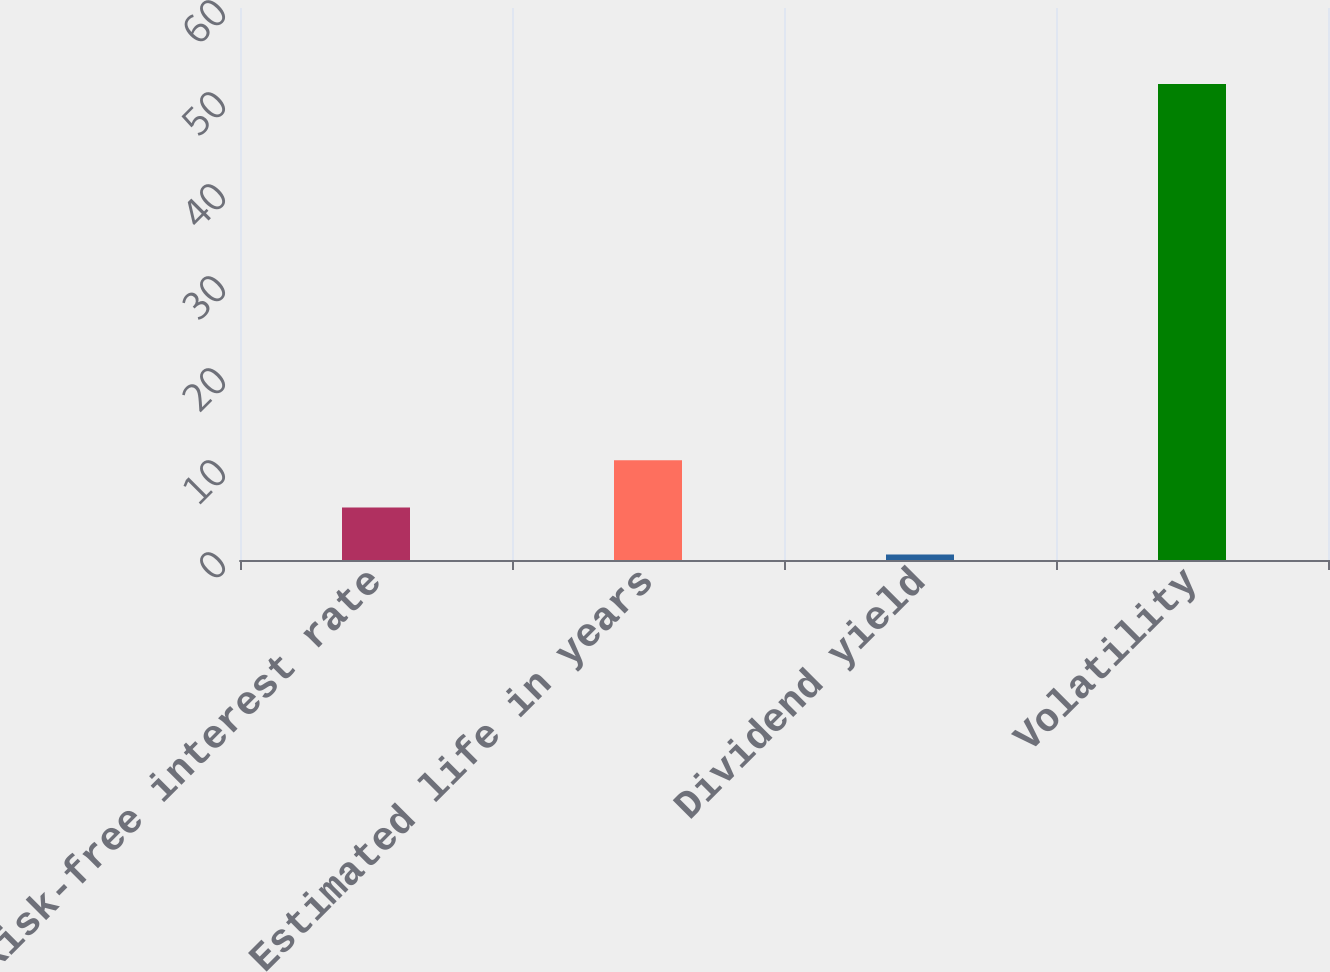Convert chart. <chart><loc_0><loc_0><loc_500><loc_500><bar_chart><fcel>Risk-free interest rate<fcel>Estimated life in years<fcel>Dividend yield<fcel>Volatility<nl><fcel>5.71<fcel>10.83<fcel>0.59<fcel>51.75<nl></chart> 